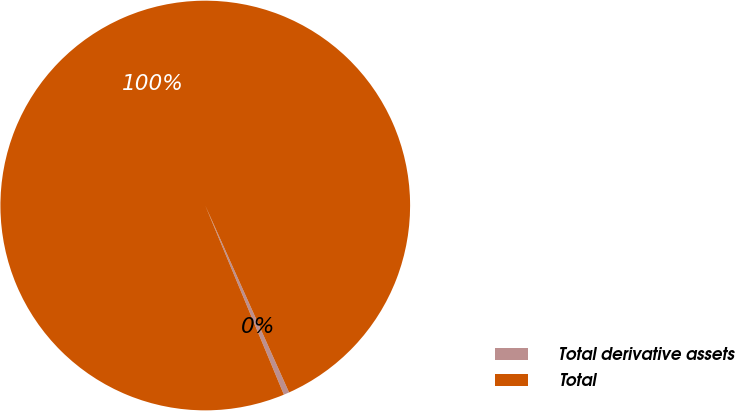Convert chart to OTSL. <chart><loc_0><loc_0><loc_500><loc_500><pie_chart><fcel>Total derivative assets<fcel>Total<nl><fcel>0.44%<fcel>99.56%<nl></chart> 